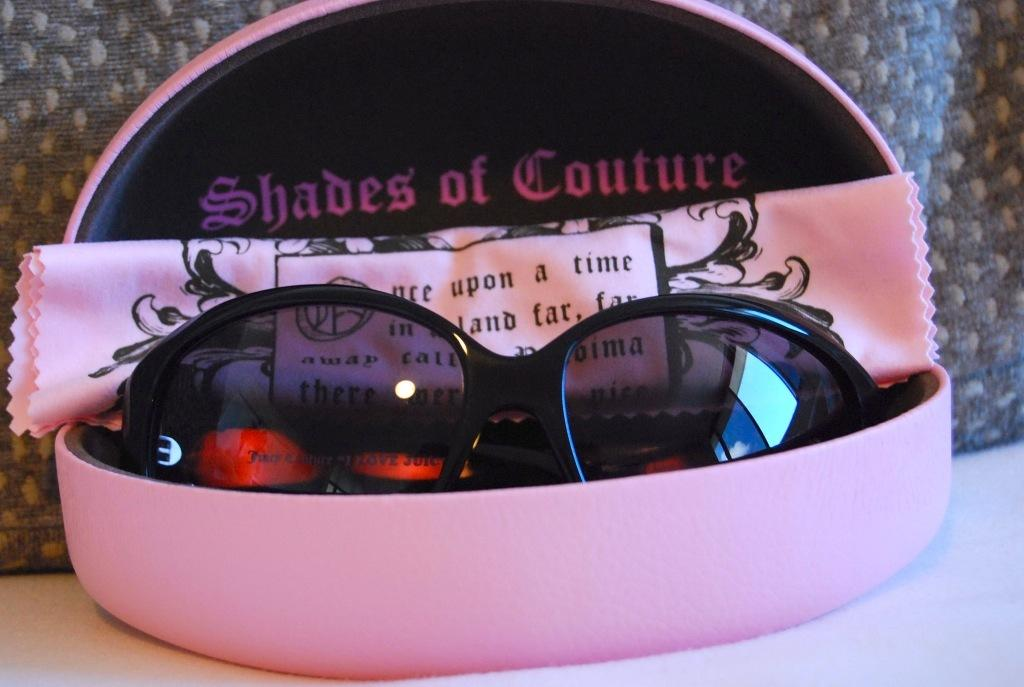What is the color of the box in the image? The box in the image is pink. What is inside the pink box? Inside the pink box, there is a pair of sunglasses. What is the pink box made of? The pink box is made of cloth. What can be seen in the background of the image? There is cloth visible in the background of the image. What type of books can be seen in the library in the image? There is no library present in the image; it features a pink box with sunglasses inside. What cast member is wearing the sunglasses in the image? There are no cast members or people present in the image, only a pink box with sunglasses inside. 